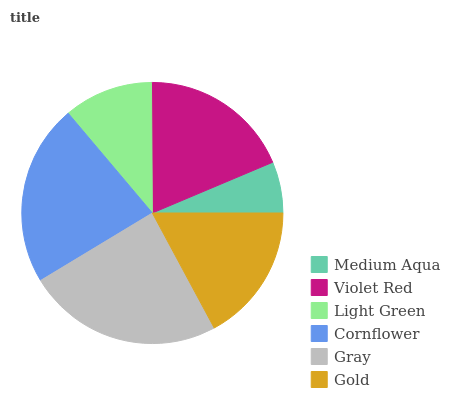Is Medium Aqua the minimum?
Answer yes or no. Yes. Is Gray the maximum?
Answer yes or no. Yes. Is Violet Red the minimum?
Answer yes or no. No. Is Violet Red the maximum?
Answer yes or no. No. Is Violet Red greater than Medium Aqua?
Answer yes or no. Yes. Is Medium Aqua less than Violet Red?
Answer yes or no. Yes. Is Medium Aqua greater than Violet Red?
Answer yes or no. No. Is Violet Red less than Medium Aqua?
Answer yes or no. No. Is Violet Red the high median?
Answer yes or no. Yes. Is Gold the low median?
Answer yes or no. Yes. Is Light Green the high median?
Answer yes or no. No. Is Violet Red the low median?
Answer yes or no. No. 